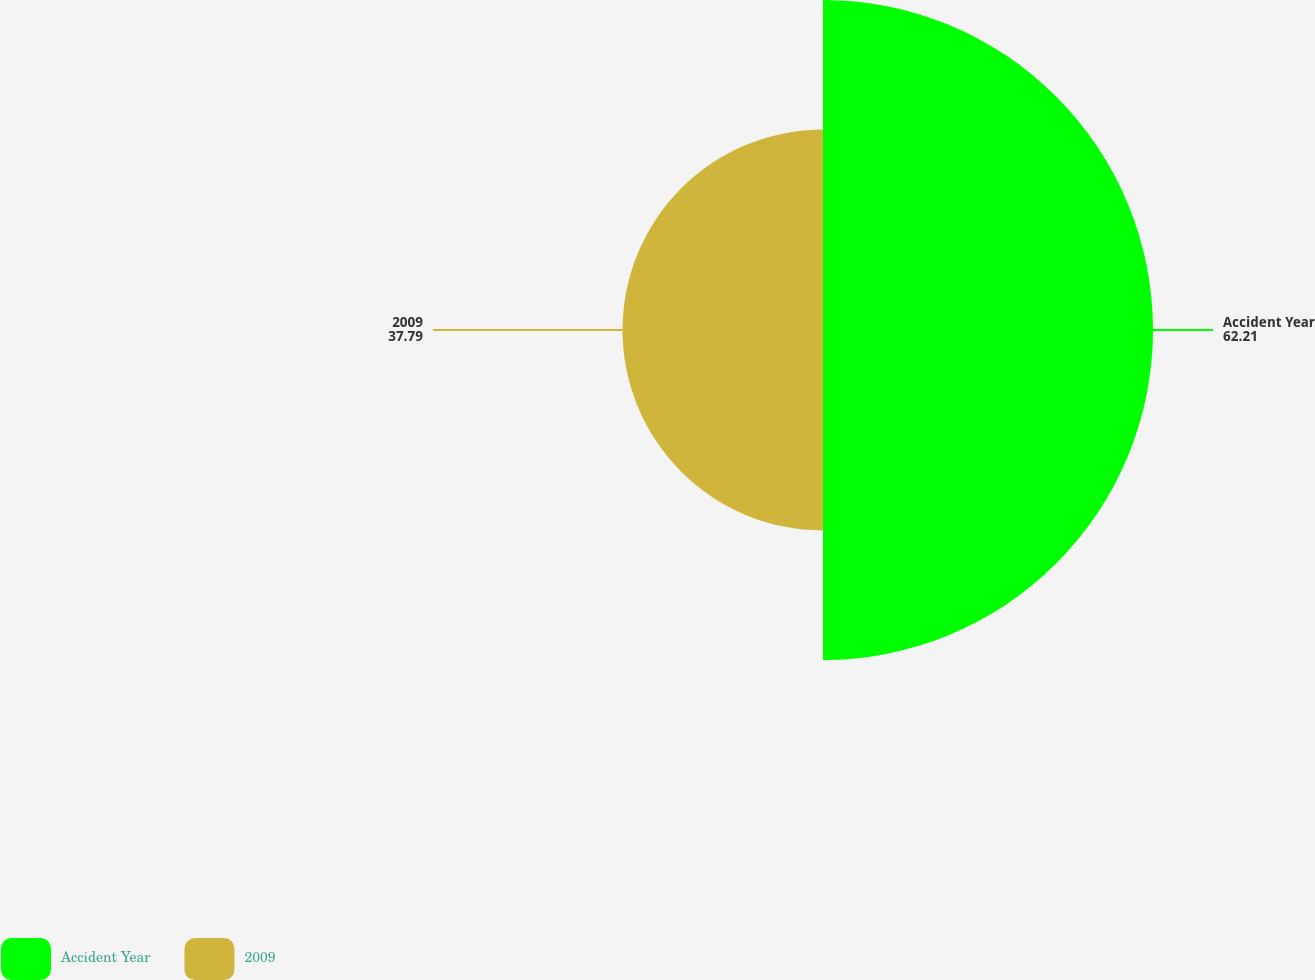<chart> <loc_0><loc_0><loc_500><loc_500><pie_chart><fcel>Accident Year<fcel>2009<nl><fcel>62.21%<fcel>37.79%<nl></chart> 